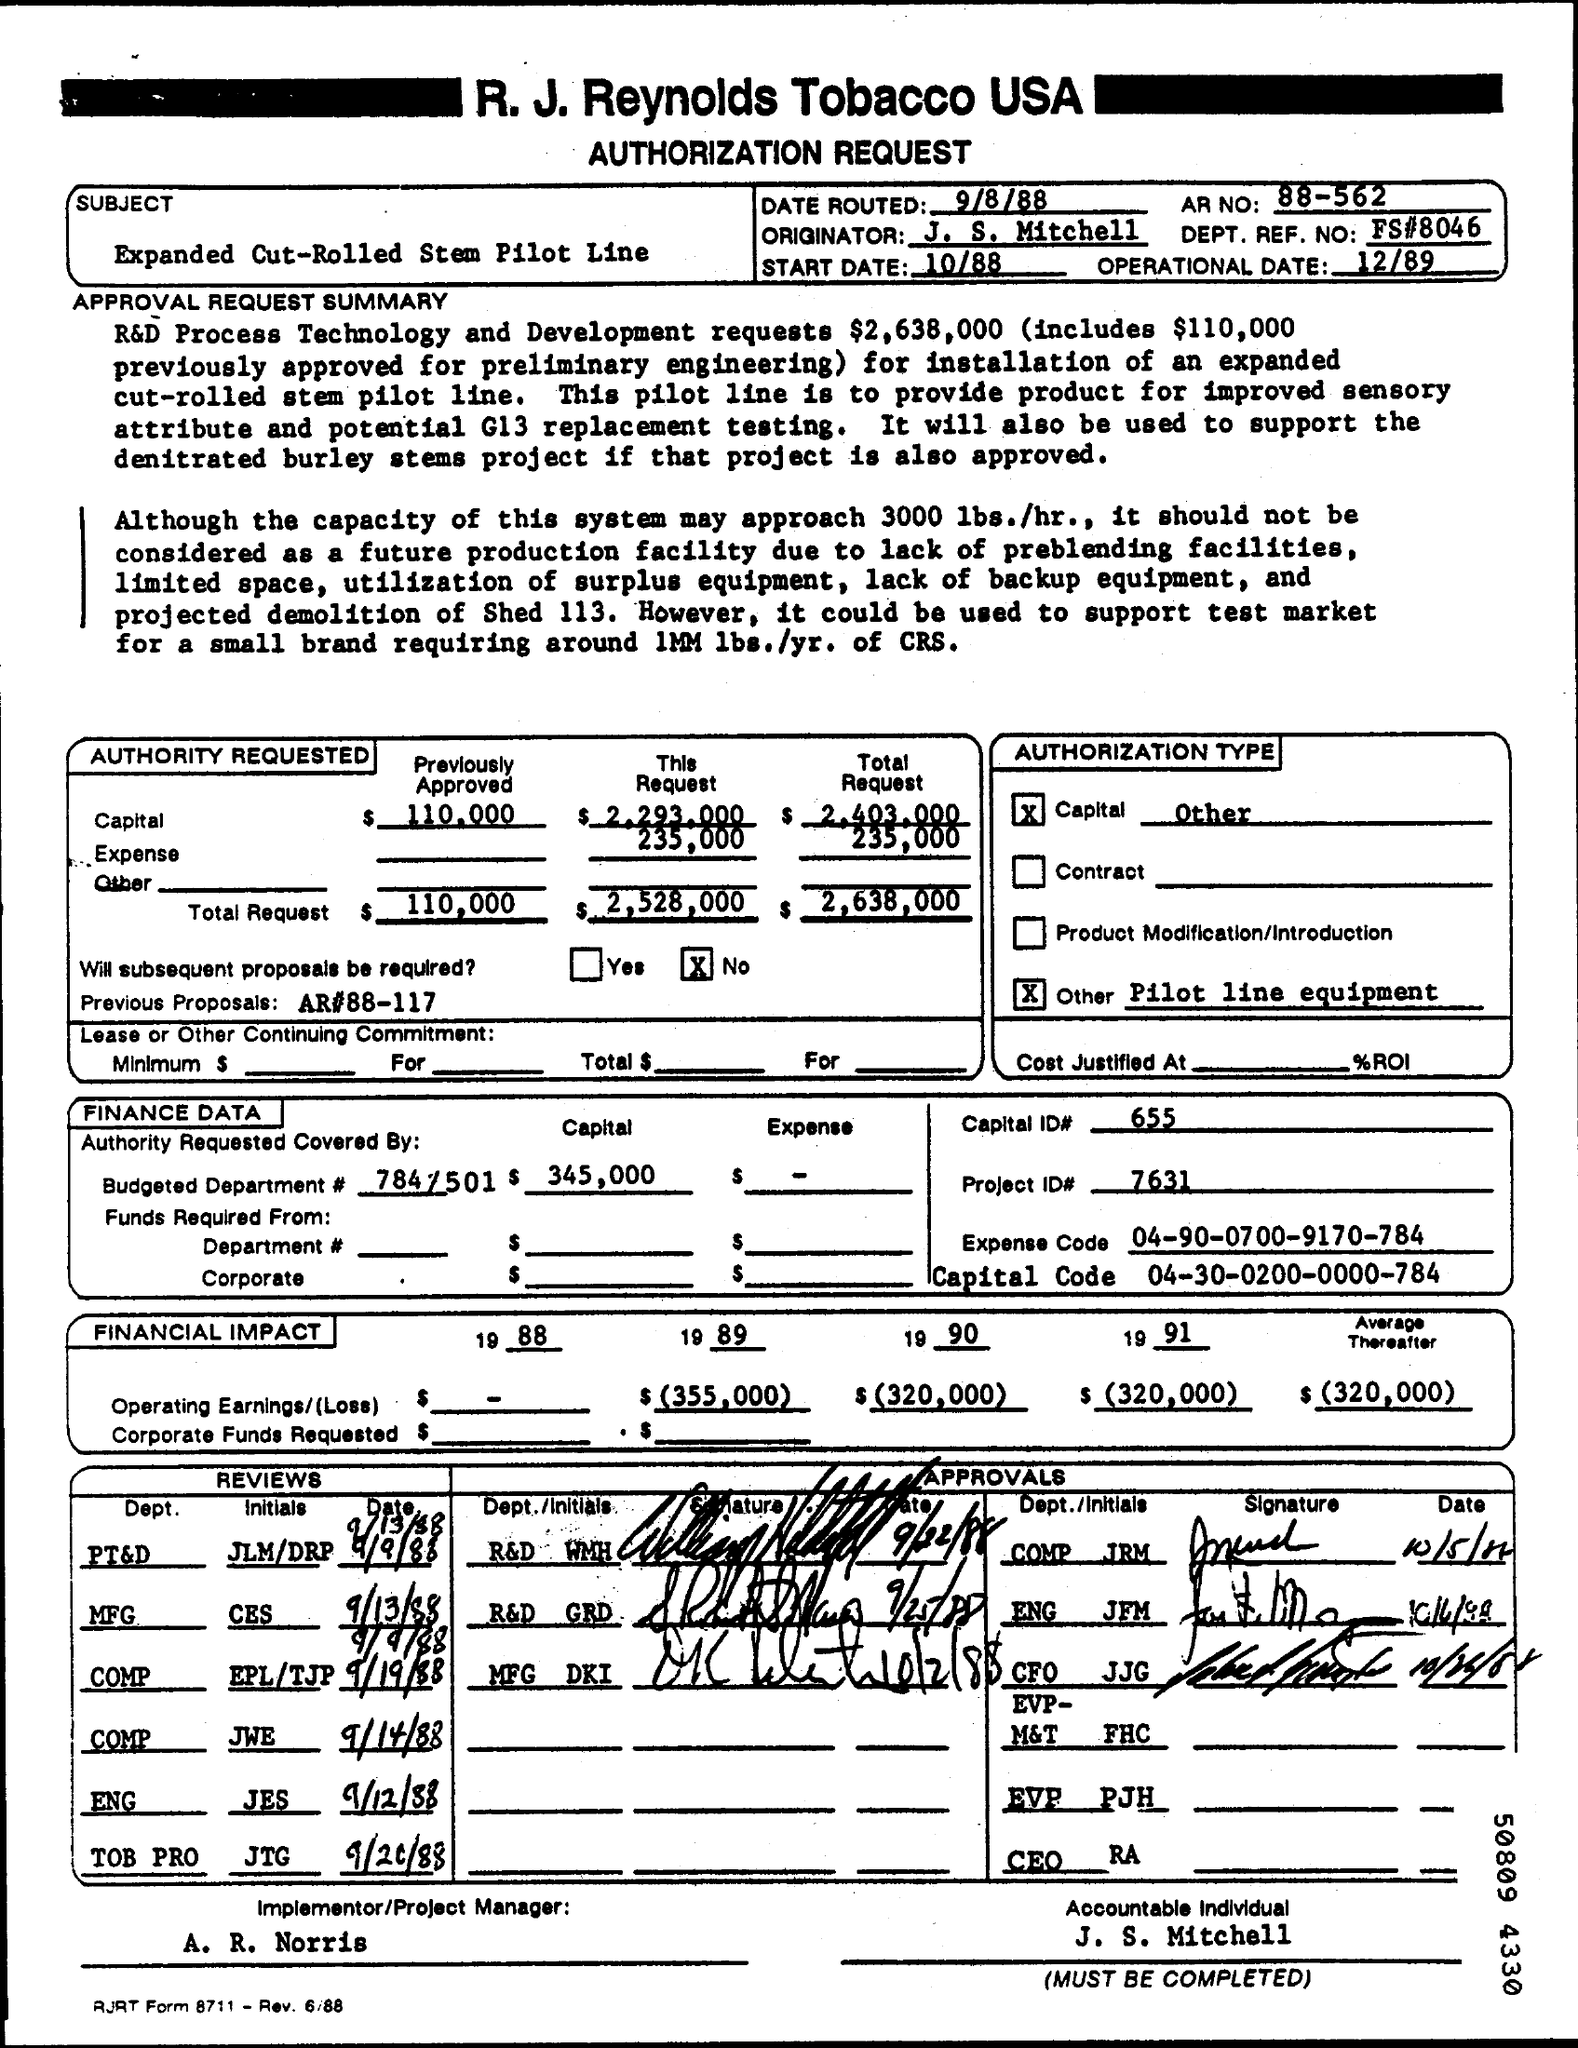Identify some key points in this picture. The previous approved amount for preliminary engineering was $110,000. The total requirement for R&D process technology and development is estimated to be $2,638,000. The accountable individual is J. S. Mitchell. 